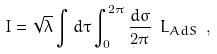<formula> <loc_0><loc_0><loc_500><loc_500>I = \sqrt { \lambda } \int d \tau \int ^ { 2 \pi } _ { 0 } \frac { d \sigma } { 2 \pi } \ L _ { A d S } \ ,</formula> 